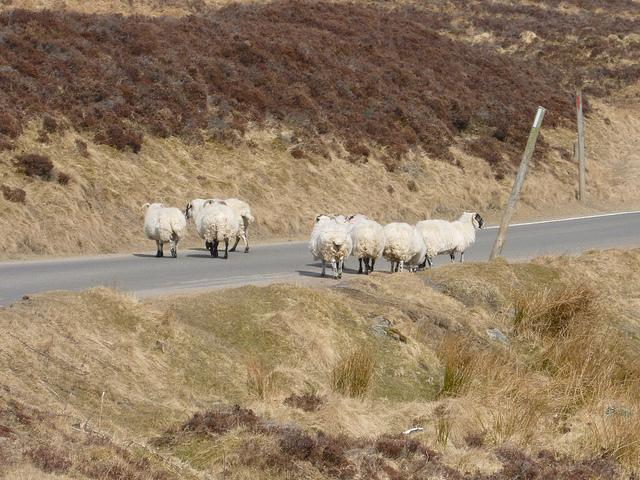What is the fur of the animal in this image commonly used for? Please explain your reasoning. carpets. The fur is like a carpet. 